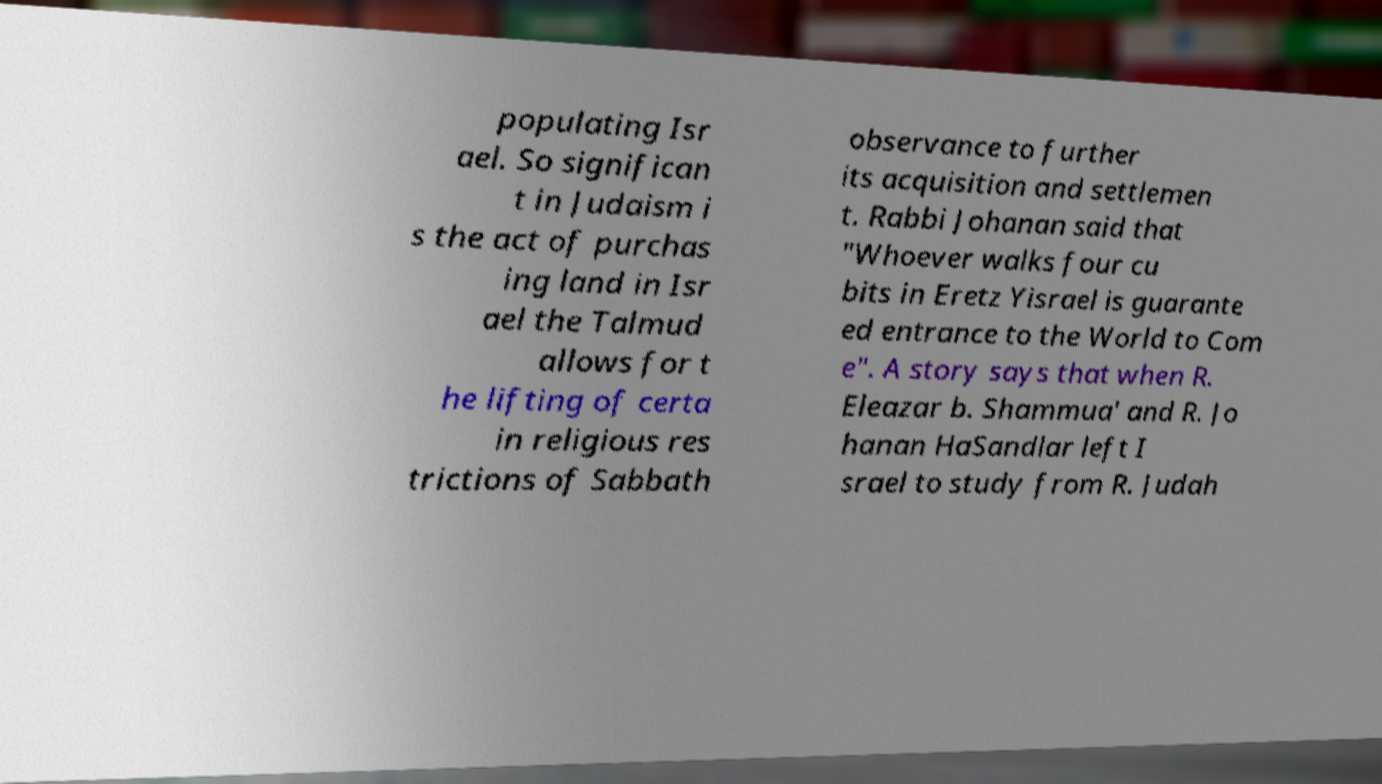I need the written content from this picture converted into text. Can you do that? populating Isr ael. So significan t in Judaism i s the act of purchas ing land in Isr ael the Talmud allows for t he lifting of certa in religious res trictions of Sabbath observance to further its acquisition and settlemen t. Rabbi Johanan said that "Whoever walks four cu bits in Eretz Yisrael is guarante ed entrance to the World to Com e". A story says that when R. Eleazar b. Shammua' and R. Jo hanan HaSandlar left I srael to study from R. Judah 